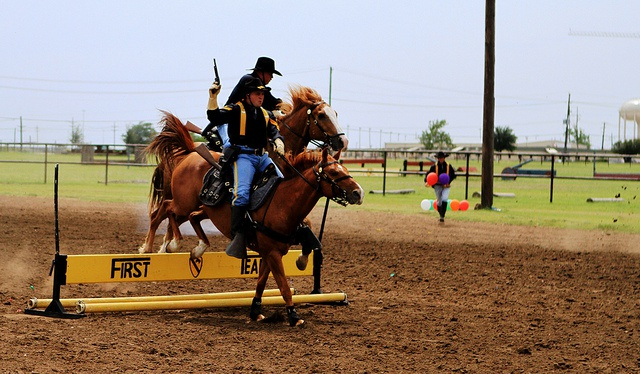Describe the objects in this image and their specific colors. I can see horse in lavender, black, maroon, and brown tones, people in lavender, black, gray, and navy tones, horse in lavender, black, maroon, lightgray, and brown tones, people in lavender, black, white, gray, and maroon tones, and people in lavender, black, gray, red, and tan tones in this image. 